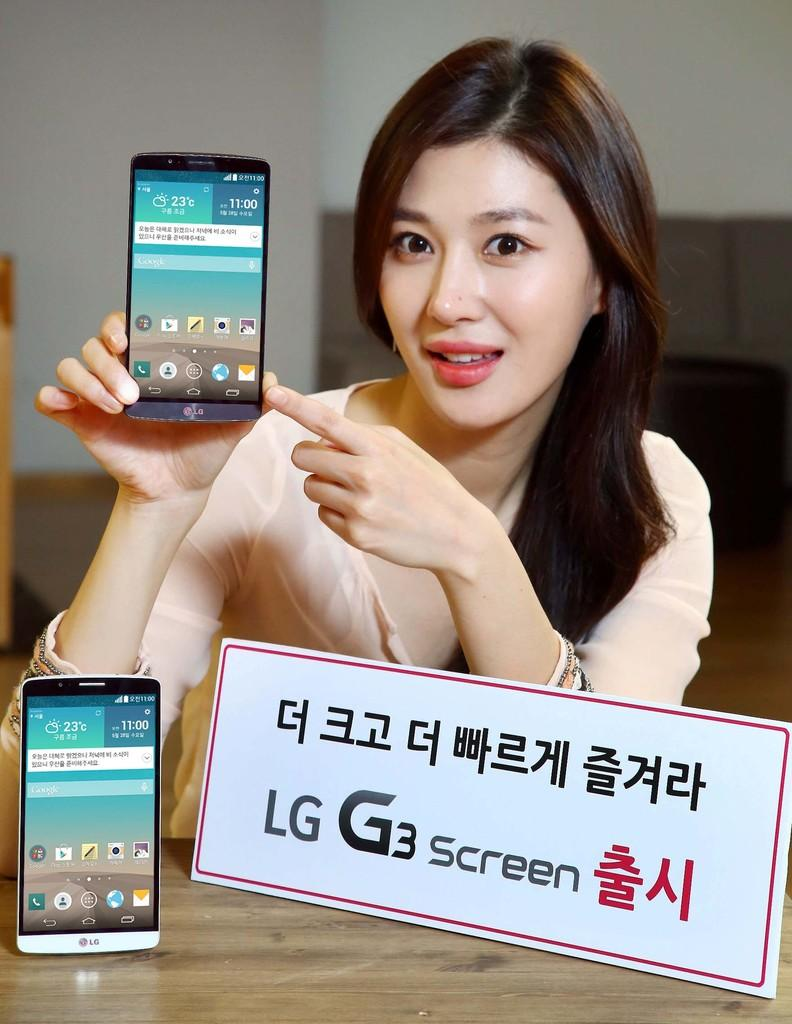<image>
Offer a succinct explanation of the picture presented. A girl holds up a phone whose clock reads 11:00. 